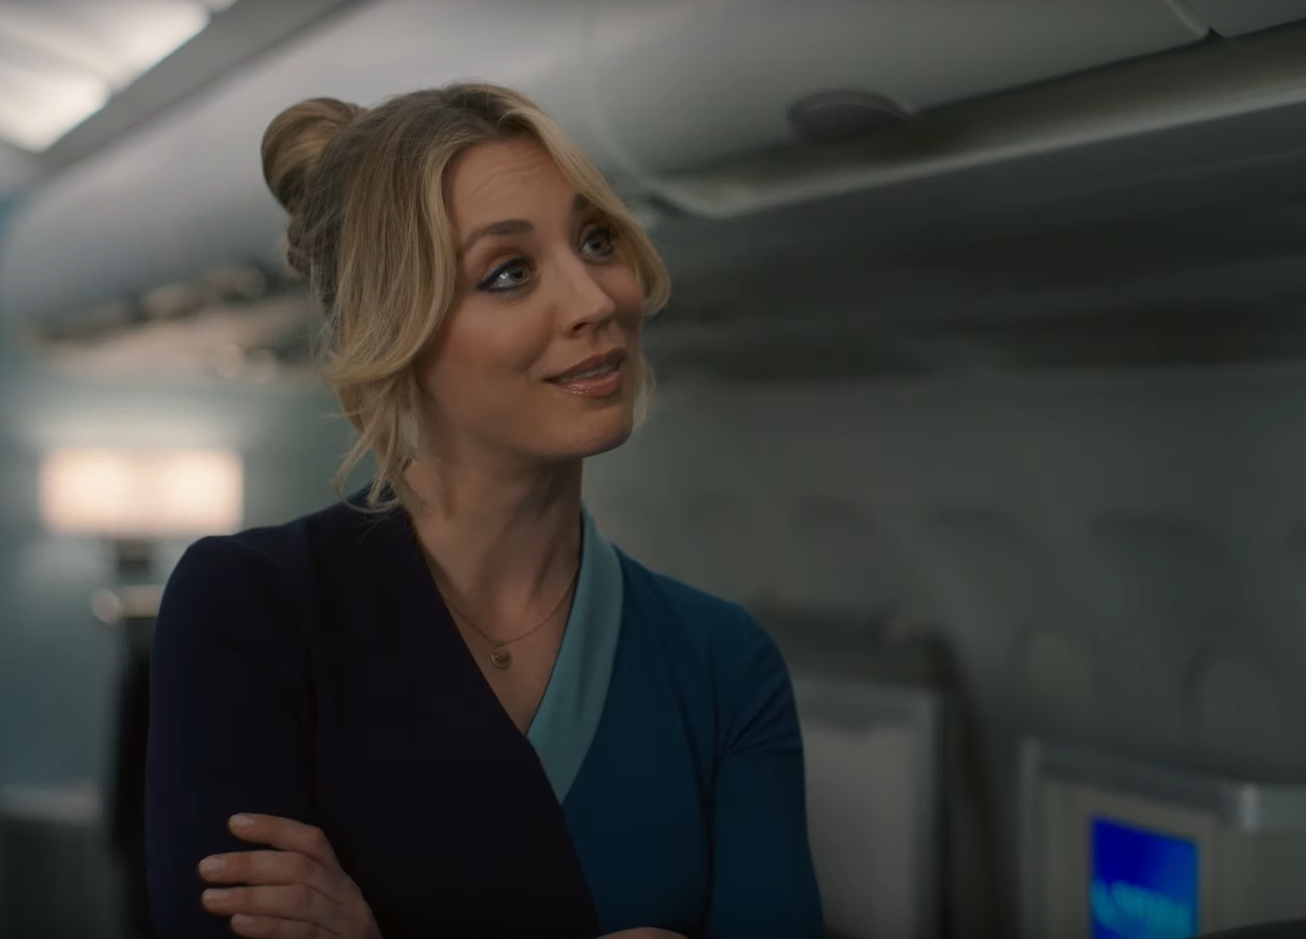Write a detailed description of the given image. The image captures a woman in a professional setting, possibly a flight attendant, positioned in the aisle of an aircraft cabin. She is dressed in a nuanced uniform consisting of a navy blue cardigan over a teal top with a matching scarf, signifying her role and authority onboard. Her hair is styled in an updo, and she has a pleasant, engaging smile, suggesting a friendly interaction, possibly with a passenger or coworker. The overhead compartments and seating arrangement typical of commercial airplanes form the backdrop, with soft lighting contributing to the cabin's ambience. The image likely portrays a moment of friendly or customer service-oriented dialogue, as part of an in-flight narrative. 